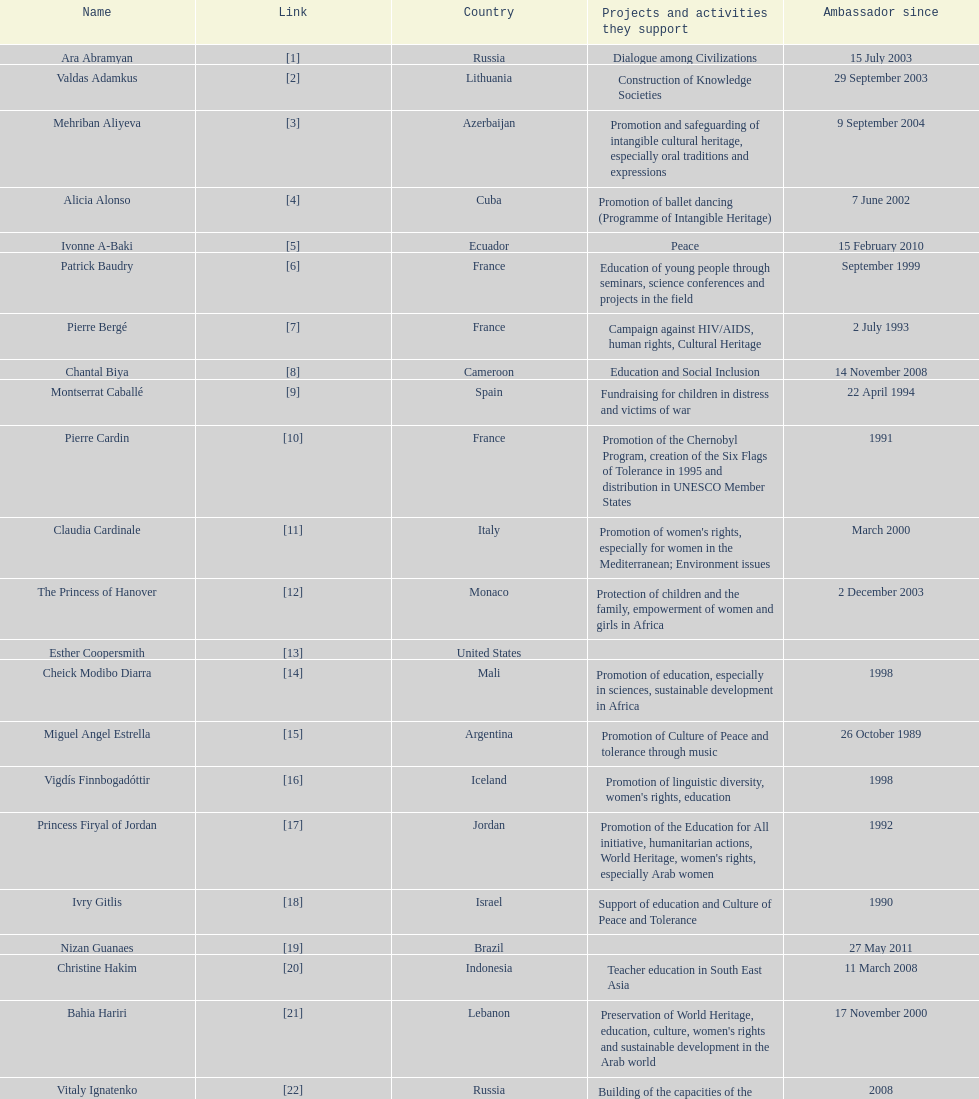Could you help me parse every detail presented in this table? {'header': ['Name', 'Link', 'Country', 'Projects and activities they support', 'Ambassador since'], 'rows': [['Ara Abramyan', '[1]', 'Russia', 'Dialogue among Civilizations', '15 July 2003'], ['Valdas Adamkus', '[2]', 'Lithuania', 'Construction of Knowledge Societies', '29 September 2003'], ['Mehriban Aliyeva', '[3]', 'Azerbaijan', 'Promotion and safeguarding of intangible cultural heritage, especially oral traditions and expressions', '9 September 2004'], ['Alicia Alonso', '[4]', 'Cuba', 'Promotion of ballet dancing (Programme of Intangible Heritage)', '7 June 2002'], ['Ivonne A-Baki', '[5]', 'Ecuador', 'Peace', '15 February 2010'], ['Patrick Baudry', '[6]', 'France', 'Education of young people through seminars, science conferences and projects in the field', 'September 1999'], ['Pierre Bergé', '[7]', 'France', 'Campaign against HIV/AIDS, human rights, Cultural Heritage', '2 July 1993'], ['Chantal Biya', '[8]', 'Cameroon', 'Education and Social Inclusion', '14 November 2008'], ['Montserrat Caballé', '[9]', 'Spain', 'Fundraising for children in distress and victims of war', '22 April 1994'], ['Pierre Cardin', '[10]', 'France', 'Promotion of the Chernobyl Program, creation of the Six Flags of Tolerance in 1995 and distribution in UNESCO Member States', '1991'], ['Claudia Cardinale', '[11]', 'Italy', "Promotion of women's rights, especially for women in the Mediterranean; Environment issues", 'March 2000'], ['The Princess of Hanover', '[12]', 'Monaco', 'Protection of children and the family, empowerment of women and girls in Africa', '2 December 2003'], ['Esther Coopersmith', '[13]', 'United States', '', ''], ['Cheick Modibo Diarra', '[14]', 'Mali', 'Promotion of education, especially in sciences, sustainable development in Africa', '1998'], ['Miguel Angel Estrella', '[15]', 'Argentina', 'Promotion of Culture of Peace and tolerance through music', '26 October 1989'], ['Vigdís Finnbogadóttir', '[16]', 'Iceland', "Promotion of linguistic diversity, women's rights, education", '1998'], ['Princess Firyal of Jordan', '[17]', 'Jordan', "Promotion of the Education for All initiative, humanitarian actions, World Heritage, women's rights, especially Arab women", '1992'], ['Ivry Gitlis', '[18]', 'Israel', 'Support of education and Culture of Peace and Tolerance', '1990'], ['Nizan Guanaes', '[19]', 'Brazil', '', '27 May 2011'], ['Christine Hakim', '[20]', 'Indonesia', 'Teacher education in South East Asia', '11 March 2008'], ['Bahia Hariri', '[21]', 'Lebanon', "Preservation of World Heritage, education, culture, women's rights and sustainable development in the Arab world", '17 November 2000'], ['Vitaly Ignatenko', '[22]', 'Russia', 'Building of the capacities of the Russian language journalists and promotion of the free circulation of ideas in the Russian-speaking world', '2008'], ['Jean Michel Jarre', '[23]', 'France', 'Protection of the environment (water, fight against desertification, renewable energies), youth and tolerance, safeguarding of World Heritage', '24 May 1993'], ['Marc Ladreit de Lacharrière', '[24]', 'France', '', '27 August 2009'], ['Princess Lalla Meryem of Morocco', '[25]', 'Morocco', "Protection of childhood and women's rights", 'July 2001'], ['Omer Zülfü Livaneli', '[26]', 'Turkey', 'Promotion of peace and polerance through music and promotion of human rights', '20 September 1996'], ['Princess Maha Chakri Sirindhorn of Thailand', '[27]', 'Thailand', 'Empowerment of Minority Children and the Preservation of their Intangible Cultural Heritage', '24 March 2005'], ['Jean Malaurie', '[28]', 'France', 'In charge of arctic polar issues, promoting environmental issues and safeguarding the culture and knowledge of the peoples of the Arctic', '17 July 2007'], ['Keith Chatsauka-Coetzee', '[29]', 'South Africa', '', '12 July 2012'], ['Grand Duchess María Teresa of Luxembourg', '[30]', 'Luxembourg', "Education, Women's rights, microfinance and campaign against poverty", '10 June 1997'], ['Rigoberta Menchu Túm', '[31]', 'Guatemala', 'Promotion of Culture of Peace, protection of rights of indigenous people', '21 June 1996'], ['Oskar Metsavaht', '[32]', 'Brazil', '', '27 May 2011'], ['Vik Muniz', '[33]', 'Brazil', '', '27 May 2011'], ['Kitín Muñoz', '[34]', 'Spain', 'Protection and promotion of indigenous cultures and their environment', '22 April 1997'], ['Ute-Henriette Ohoven', '[35]', 'Germany', 'UNESCO Special Ambassador for Education of Children in Need', '1992'], ['Cristina Owen-Jones', '[36]', 'Italy', 'HIV/AIDS Prevention Education Program', '23 March 2004'], ['Kim Phuc Phan Thi', '[37]', 'Vietnam', 'Protection and education for children, orphans and innocent victims of war', '10 November 1994'], ['Susana Rinaldi', '[38]', 'Argentina', 'Street children, Culture of Peace', '28 April 1992'], ['Yazid Sabeg', '[39]', 'Algeria', '', '16 February 2010'], ['Sheikh Ghassan I. Shaker', '[40]', 'Saudi Arabia', 'Fundraising, children and women in need, victims of war, education, microfinance', '1989'], ['Hayat Sindi', '[41]', 'Saudi Arabia', 'Promotion of science education for Arab women', '1 October 2012'], ['Madanjeet Singh', '[42]', 'India', 'Founder of the South Asia Foundation, which promotes regional cooperation through education and sustainable development', '16 November 2000'], ['Zurab Tsereteli', '[43]', 'Georgia', 'Cultural and artistic projects', '30 March 1996'], ['Giancarlo Elia Valori', '[44]', 'Italy', 'Safeguarding of Intangible Heritage', '2001'], ['Marianna Vardinoyannis', '[45]', 'Greece', 'Protection of childhood; promotion of cultural olympics; humanitarian relief for war victims', '21 October 1999'], ['Milú Villela', '[46]', 'Brazil', 'Voluntary Action and Basic Education in Latin America', '10 November 2004'], ['Forest Whitaker', '[47]', 'United States', '', ''], ['Sunny Varkey', '[48]', 'India', 'Promoter of education', ''], ['Laura Welch Bush', '[49]', 'United States', 'UNESCO Honorary Ambassador for the Decade of Literacy in the context of the United Nations Literacy Decade (2003–2012)', '13 February 2003']]} Which unesco goodwill ambassador is most known for the promotion of the chernobyl program? Pierre Cardin. 